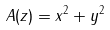Convert formula to latex. <formula><loc_0><loc_0><loc_500><loc_500>A ( z ) = x ^ { 2 } + y ^ { 2 }</formula> 